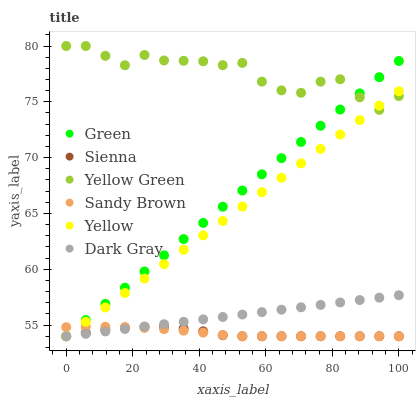Does Sienna have the minimum area under the curve?
Answer yes or no. Yes. Does Yellow Green have the maximum area under the curve?
Answer yes or no. Yes. Does Yellow have the minimum area under the curve?
Answer yes or no. No. Does Yellow have the maximum area under the curve?
Answer yes or no. No. Is Dark Gray the smoothest?
Answer yes or no. Yes. Is Yellow Green the roughest?
Answer yes or no. Yes. Is Yellow the smoothest?
Answer yes or no. No. Is Yellow the roughest?
Answer yes or no. No. Does Dark Gray have the lowest value?
Answer yes or no. Yes. Does Yellow Green have the lowest value?
Answer yes or no. No. Does Yellow Green have the highest value?
Answer yes or no. Yes. Does Yellow have the highest value?
Answer yes or no. No. Is Dark Gray less than Yellow Green?
Answer yes or no. Yes. Is Yellow Green greater than Sandy Brown?
Answer yes or no. Yes. Does Sandy Brown intersect Green?
Answer yes or no. Yes. Is Sandy Brown less than Green?
Answer yes or no. No. Is Sandy Brown greater than Green?
Answer yes or no. No. Does Dark Gray intersect Yellow Green?
Answer yes or no. No. 